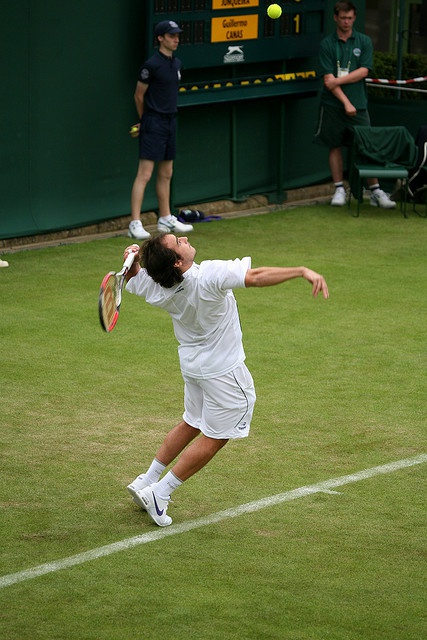Describe the objects in this image and their specific colors. I can see people in black, lightgray, darkgray, and gray tones, people in black, maroon, brown, and gray tones, people in black, gray, and maroon tones, chair in black, teal, and darkgreen tones, and tennis racket in black, tan, white, olive, and gray tones in this image. 